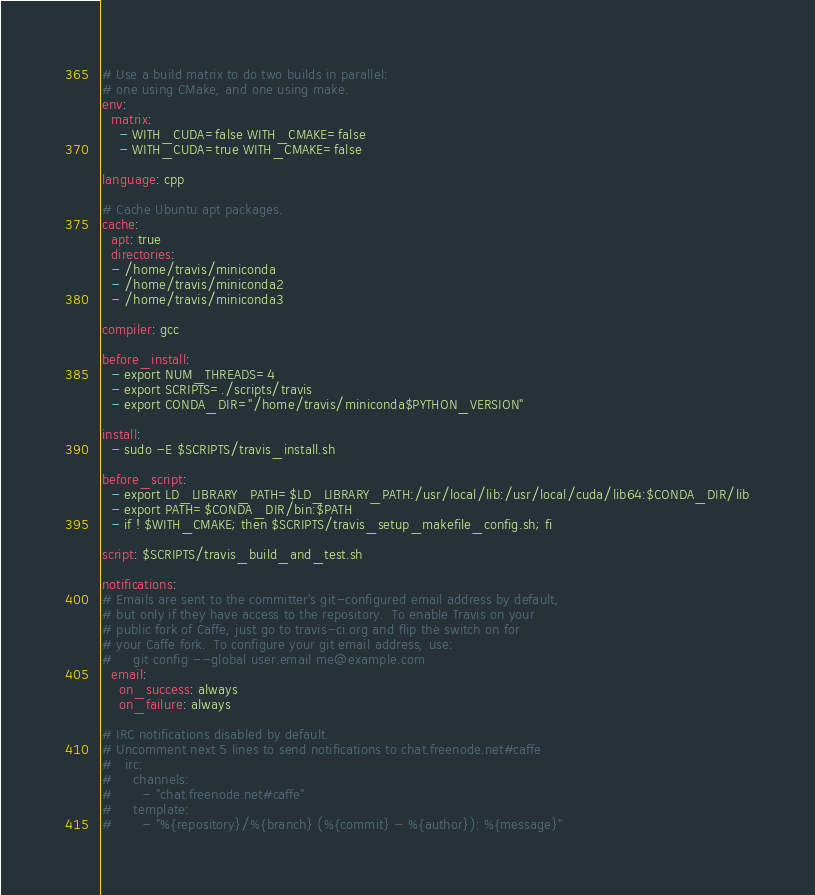<code> <loc_0><loc_0><loc_500><loc_500><_YAML_># Use a build matrix to do two builds in parallel:
# one using CMake, and one using make.
env:
  matrix:
    - WITH_CUDA=false WITH_CMAKE=false
    - WITH_CUDA=true WITH_CMAKE=false

language: cpp

# Cache Ubuntu apt packages.
cache:
  apt: true
  directories:
  - /home/travis/miniconda
  - /home/travis/miniconda2
  - /home/travis/miniconda3

compiler: gcc

before_install:
  - export NUM_THREADS=4
  - export SCRIPTS=./scripts/travis
  - export CONDA_DIR="/home/travis/miniconda$PYTHON_VERSION"

install:
  - sudo -E $SCRIPTS/travis_install.sh

before_script:
  - export LD_LIBRARY_PATH=$LD_LIBRARY_PATH:/usr/local/lib:/usr/local/cuda/lib64:$CONDA_DIR/lib
  - export PATH=$CONDA_DIR/bin:$PATH
  - if ! $WITH_CMAKE; then $SCRIPTS/travis_setup_makefile_config.sh; fi

script: $SCRIPTS/travis_build_and_test.sh

notifications:
# Emails are sent to the committer's git-configured email address by default,
# but only if they have access to the repository.  To enable Travis on your
# public fork of Caffe, just go to travis-ci.org and flip the switch on for
# your Caffe fork.  To configure your git email address, use:
#     git config --global user.email me@example.com
  email:
    on_success: always
    on_failure: always

# IRC notifications disabled by default.
# Uncomment next 5 lines to send notifications to chat.freenode.net#caffe
#   irc:
#     channels:
#       - "chat.freenode.net#caffe"
#     template:
#       - "%{repository}/%{branch} (%{commit} - %{author}): %{message}"
</code> 